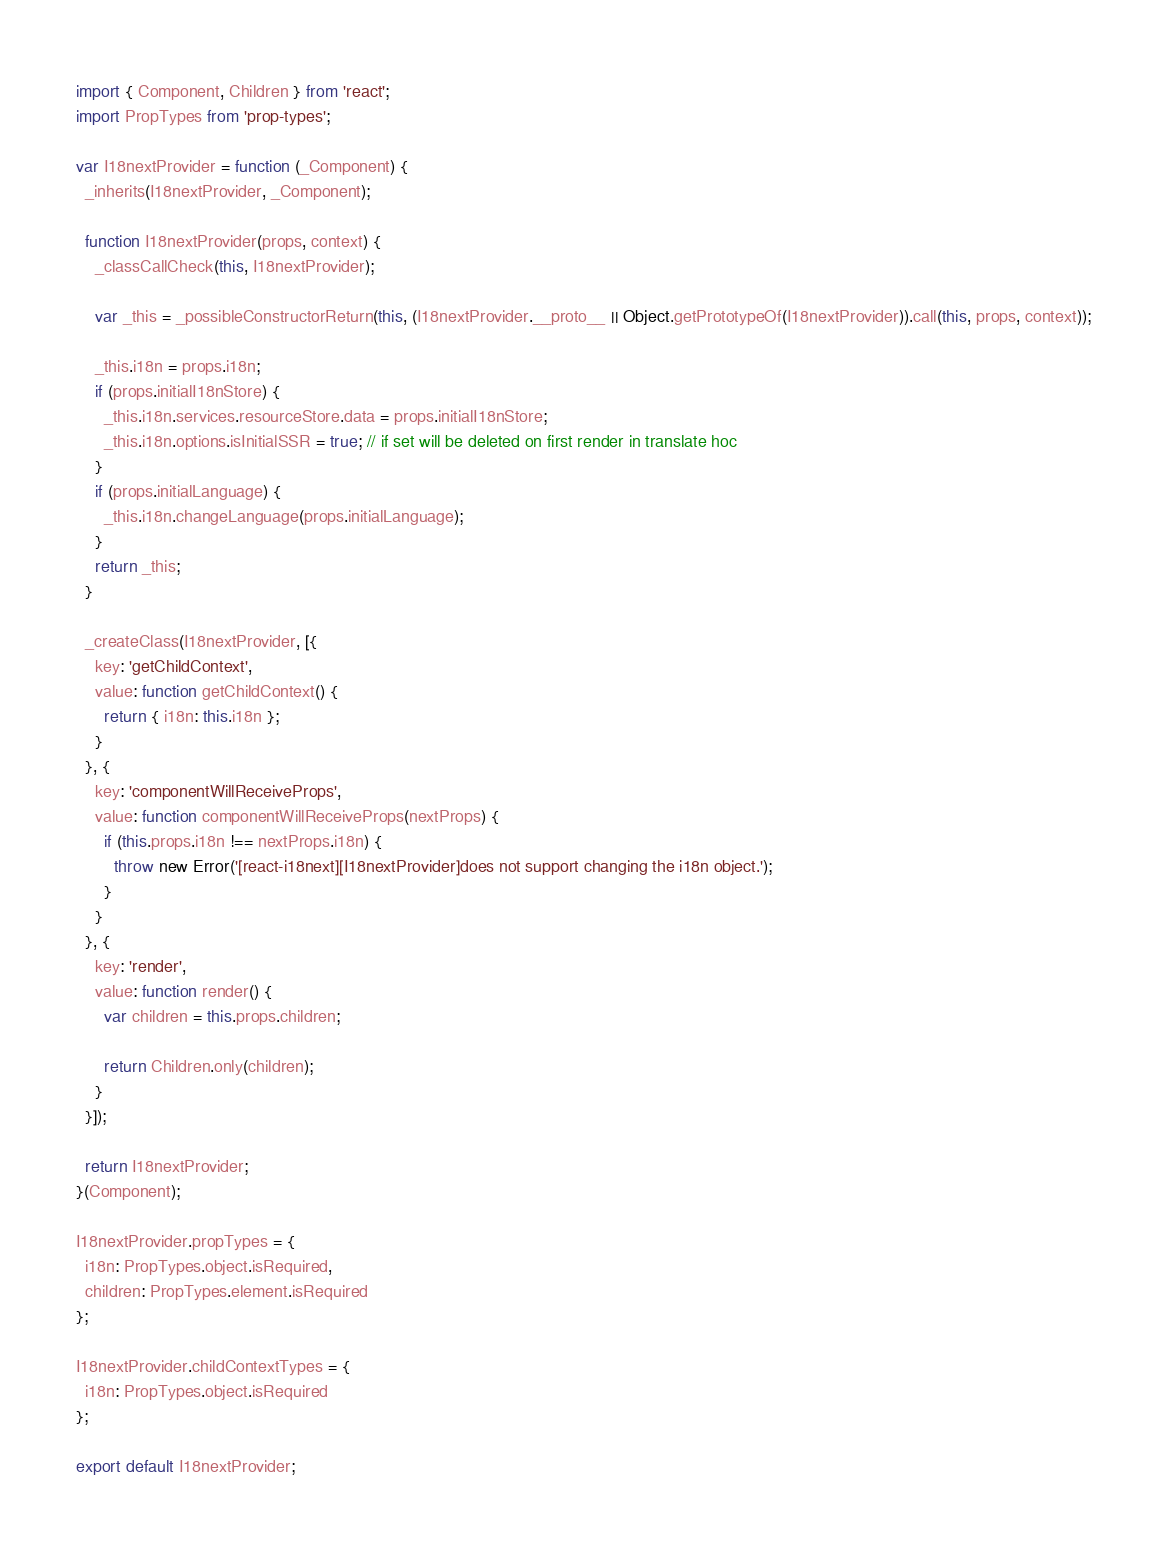<code> <loc_0><loc_0><loc_500><loc_500><_JavaScript_>import { Component, Children } from 'react';
import PropTypes from 'prop-types';

var I18nextProvider = function (_Component) {
  _inherits(I18nextProvider, _Component);

  function I18nextProvider(props, context) {
    _classCallCheck(this, I18nextProvider);

    var _this = _possibleConstructorReturn(this, (I18nextProvider.__proto__ || Object.getPrototypeOf(I18nextProvider)).call(this, props, context));

    _this.i18n = props.i18n;
    if (props.initialI18nStore) {
      _this.i18n.services.resourceStore.data = props.initialI18nStore;
      _this.i18n.options.isInitialSSR = true; // if set will be deleted on first render in translate hoc
    }
    if (props.initialLanguage) {
      _this.i18n.changeLanguage(props.initialLanguage);
    }
    return _this;
  }

  _createClass(I18nextProvider, [{
    key: 'getChildContext',
    value: function getChildContext() {
      return { i18n: this.i18n };
    }
  }, {
    key: 'componentWillReceiveProps',
    value: function componentWillReceiveProps(nextProps) {
      if (this.props.i18n !== nextProps.i18n) {
        throw new Error('[react-i18next][I18nextProvider]does not support changing the i18n object.');
      }
    }
  }, {
    key: 'render',
    value: function render() {
      var children = this.props.children;

      return Children.only(children);
    }
  }]);

  return I18nextProvider;
}(Component);

I18nextProvider.propTypes = {
  i18n: PropTypes.object.isRequired,
  children: PropTypes.element.isRequired
};

I18nextProvider.childContextTypes = {
  i18n: PropTypes.object.isRequired
};

export default I18nextProvider;</code> 